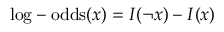<formula> <loc_0><loc_0><loc_500><loc_500>{ \log - o d d s } ( x ) = I ( \ln o t x ) - I ( x )</formula> 